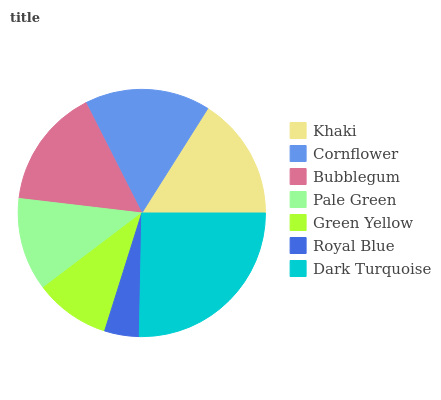Is Royal Blue the minimum?
Answer yes or no. Yes. Is Dark Turquoise the maximum?
Answer yes or no. Yes. Is Cornflower the minimum?
Answer yes or no. No. Is Cornflower the maximum?
Answer yes or no. No. Is Cornflower greater than Khaki?
Answer yes or no. Yes. Is Khaki less than Cornflower?
Answer yes or no. Yes. Is Khaki greater than Cornflower?
Answer yes or no. No. Is Cornflower less than Khaki?
Answer yes or no. No. Is Bubblegum the high median?
Answer yes or no. Yes. Is Bubblegum the low median?
Answer yes or no. Yes. Is Royal Blue the high median?
Answer yes or no. No. Is Cornflower the low median?
Answer yes or no. No. 